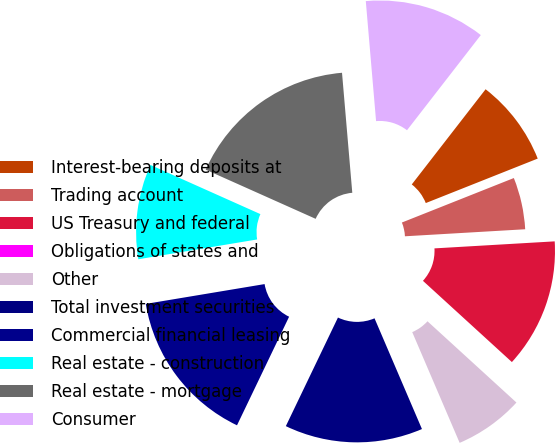Convert chart to OTSL. <chart><loc_0><loc_0><loc_500><loc_500><pie_chart><fcel>Interest-bearing deposits at<fcel>Trading account<fcel>US Treasury and federal<fcel>Obligations of states and<fcel>Other<fcel>Total investment securities<fcel>Commercial financial leasing<fcel>Real estate - construction<fcel>Real estate - mortgage<fcel>Consumer<nl><fcel>8.48%<fcel>5.09%<fcel>12.71%<fcel>0.0%<fcel>6.78%<fcel>13.56%<fcel>15.25%<fcel>9.32%<fcel>16.95%<fcel>11.86%<nl></chart> 